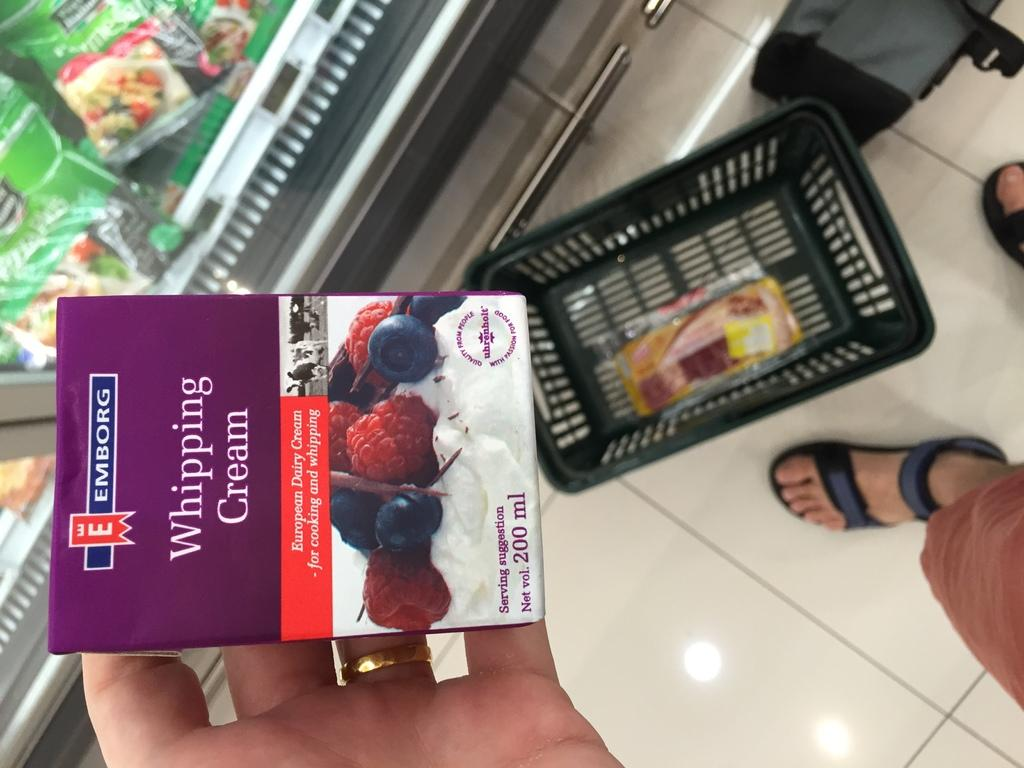<image>
Summarize the visual content of the image. A person is holding a package of Whipping Cream in a grocery store 